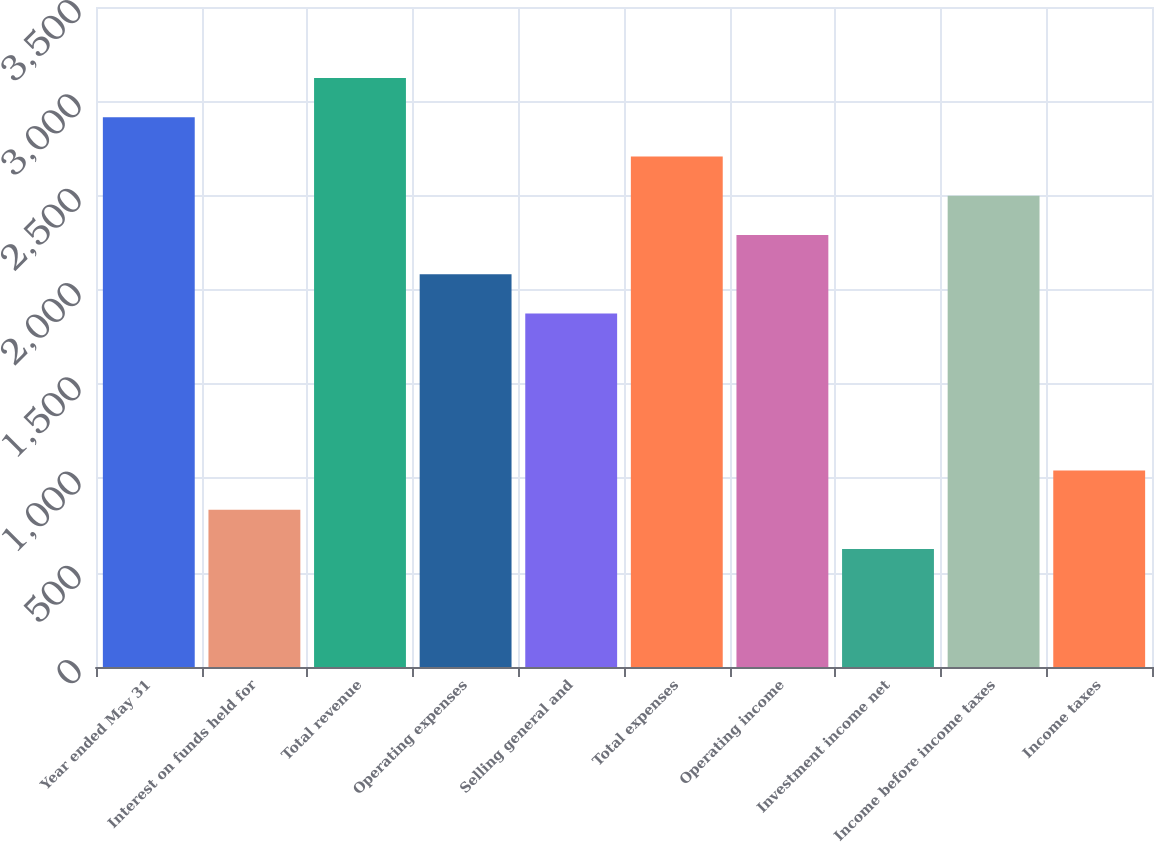Convert chart to OTSL. <chart><loc_0><loc_0><loc_500><loc_500><bar_chart><fcel>Year ended May 31<fcel>Interest on funds held for<fcel>Total revenue<fcel>Operating expenses<fcel>Selling general and<fcel>Total expenses<fcel>Operating income<fcel>Investment income net<fcel>Income before income taxes<fcel>Income taxes<nl><fcel>2915.48<fcel>833.88<fcel>3123.64<fcel>2082.84<fcel>1874.68<fcel>2707.32<fcel>2291<fcel>625.72<fcel>2499.16<fcel>1042.04<nl></chart> 